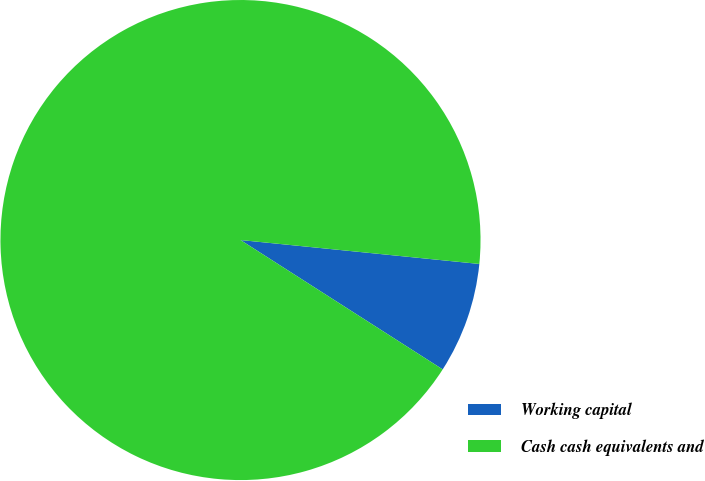<chart> <loc_0><loc_0><loc_500><loc_500><pie_chart><fcel>Working capital<fcel>Cash cash equivalents and<nl><fcel>7.47%<fcel>92.53%<nl></chart> 